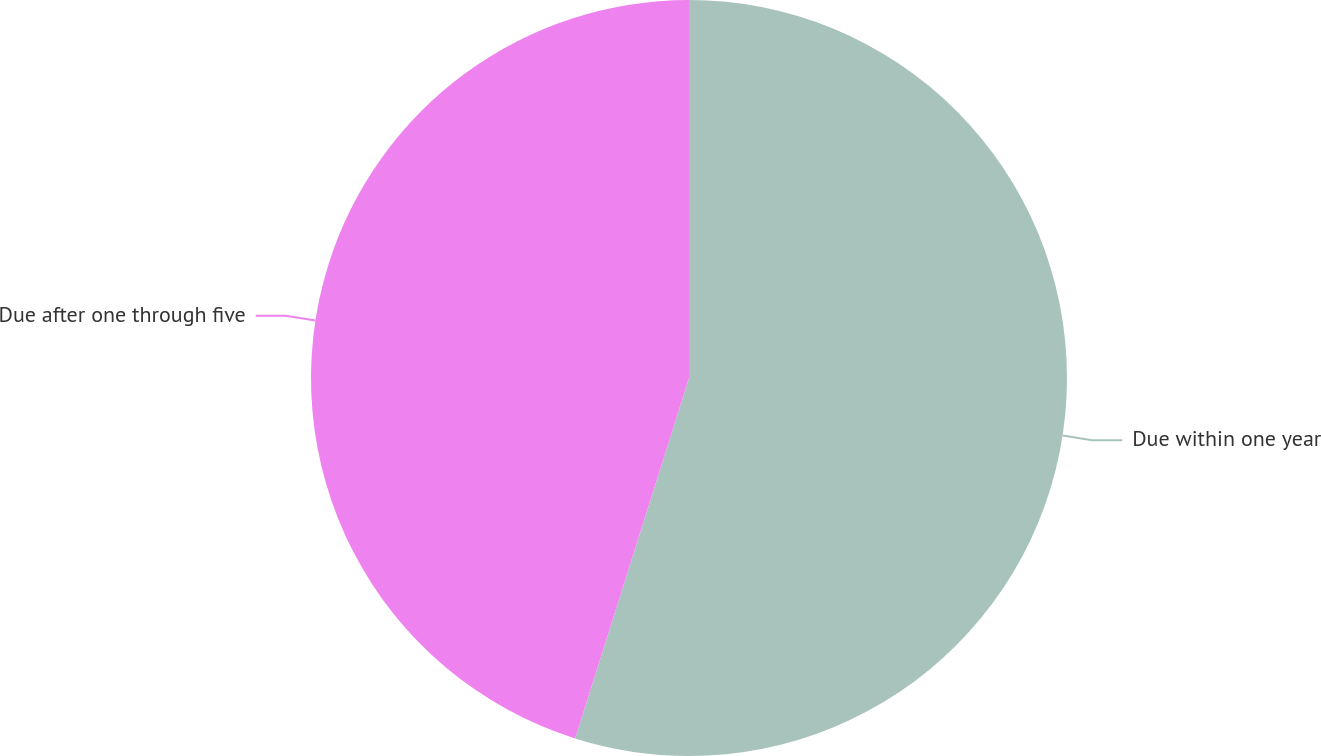<chart> <loc_0><loc_0><loc_500><loc_500><pie_chart><fcel>Due within one year<fcel>Due after one through five<nl><fcel>54.87%<fcel>45.13%<nl></chart> 